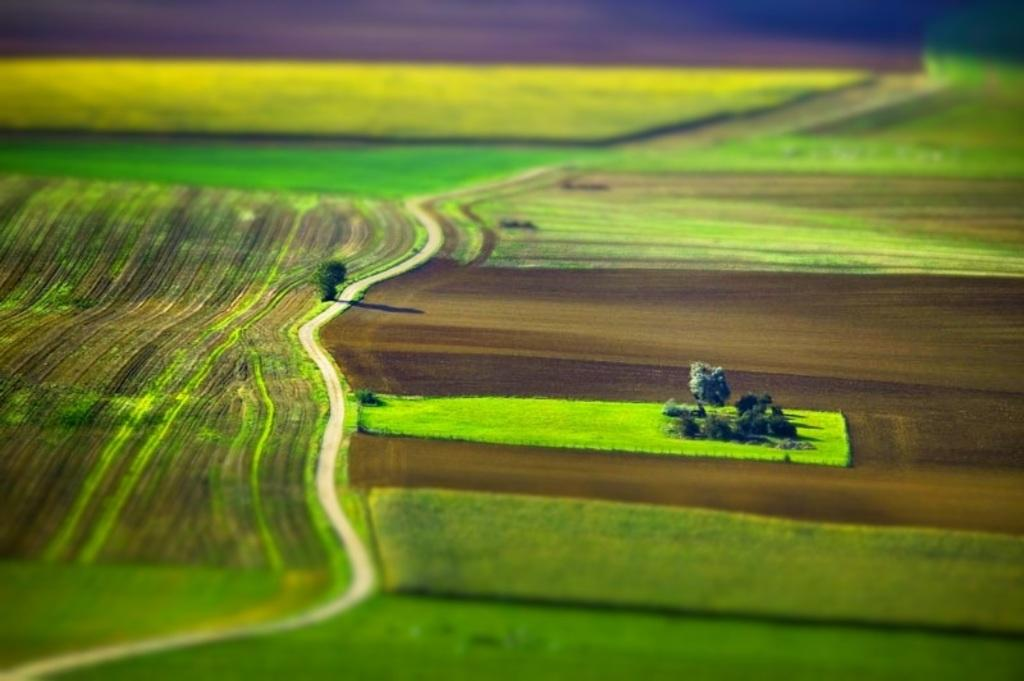What can be seen on the ground in the image? The ground is visible in the image. What type of vegetation is present in the image? There are trees and plants in the image. What is the color of the trees, plants, and grass in the image? The trees, plants, and grass are in green color. What type of bun is being used to hold the plants in the image? There is no bun present in the image; the plants are growing naturally in the ground. 